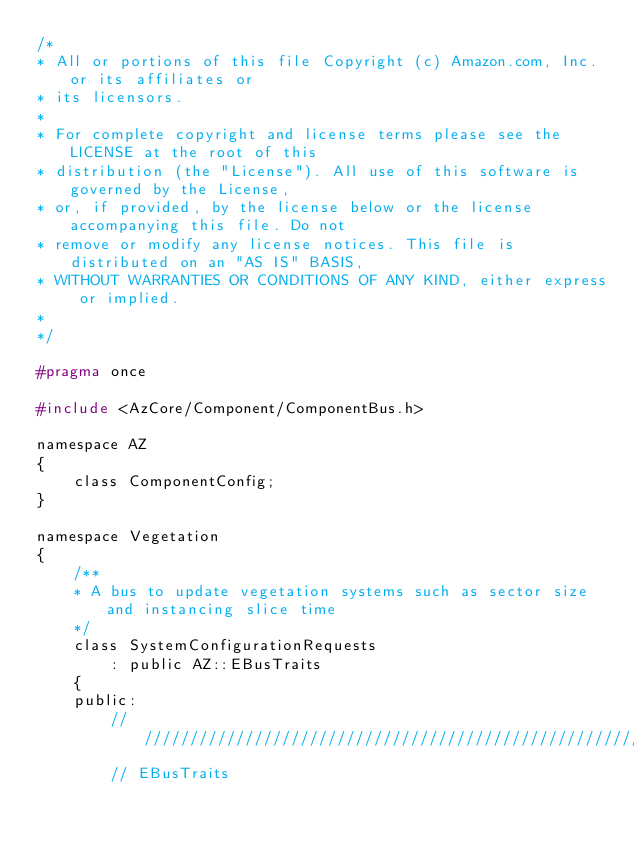Convert code to text. <code><loc_0><loc_0><loc_500><loc_500><_C_>/*
* All or portions of this file Copyright (c) Amazon.com, Inc. or its affiliates or
* its licensors.
*
* For complete copyright and license terms please see the LICENSE at the root of this
* distribution (the "License"). All use of this software is governed by the License,
* or, if provided, by the license below or the license accompanying this file. Do not
* remove or modify any license notices. This file is distributed on an "AS IS" BASIS,
* WITHOUT WARRANTIES OR CONDITIONS OF ANY KIND, either express or implied.
* 
*/

#pragma once

#include <AzCore/Component/ComponentBus.h>

namespace AZ
{
    class ComponentConfig;
}

namespace Vegetation
{
    /**
    * A bus to update vegetation systems such as sector size and instancing slice time
    */
    class SystemConfigurationRequests
        : public AZ::EBusTraits
    {
    public:
        ////////////////////////////////////////////////////////////////////////
        // EBusTraits</code> 